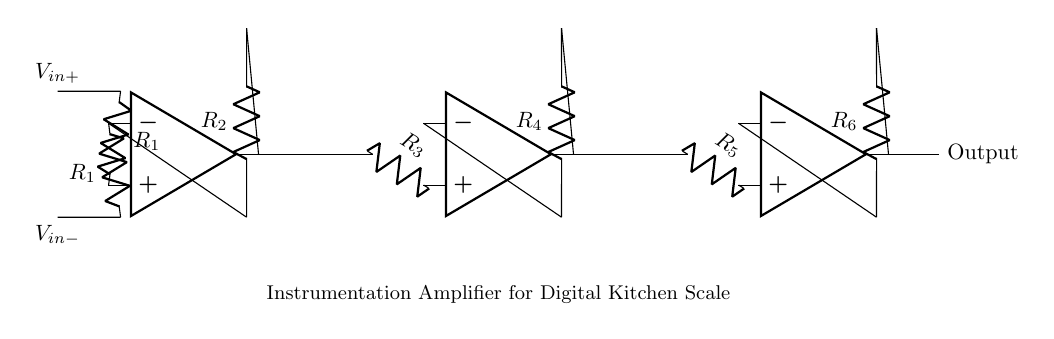What type of amplifier is depicted in the diagram? The circuit depicts an instrumentation amplifier, which is characterized by its three operational amplifiers configured to achieve high input impedance and differential gain.
Answer: instrumentation amplifier How many resistors are present in the circuit? There are six resistors in the circuit, labeled R1, R2, R3, R4, R5, and R6. Each plays a role in defining the gain and behavior of the amplifier.
Answer: six What is the role of the operational amplifiers in this circuit? The operational amplifiers serve to amplify the difference between the two input voltages while rejecting any common-mode signals, making them ideal for precise measurements.
Answer: amplify difference What are the input voltages for the instrumentation amplifier? The input voltages are V_in+ and V_in-, which are applied to the non-inverting and inverting terminals of the first operational amplifier, respectively.
Answer: V_in+ and V_in- Which resistors are involved in the feedback loop of the first operational amplifier? The feedback loop of the first operational amplifier involves resistor R2, which connects the output back to its inverting input.
Answer: R2 How does the configuration of the three operational amplifiers contribute to the amplifier's performance? The configuration of three operational amplifiers allows for increased input impedance, improved common-mode rejection ratio, and greater sensitivity, essential for accurate measurements in applications like digital kitchen scales.
Answer: increased precision What is the output of the circuit connected to? The output of the circuit is labeled simply as "Output," which indicates that it provides the amplified signal usable for further processing or display.
Answer: Output 